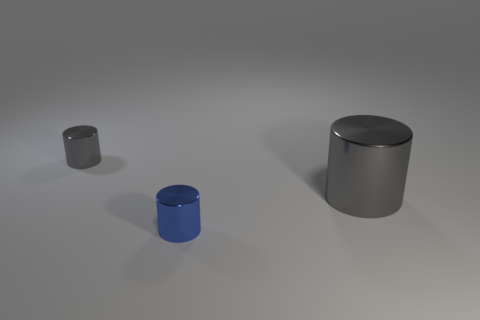Subtract all tiny metal cylinders. How many cylinders are left? 1 Add 2 gray metallic cylinders. How many objects exist? 5 Subtract all gray cylinders. How many cylinders are left? 1 Subtract 2 cylinders. How many cylinders are left? 1 Subtract all red balls. How many gray cylinders are left? 2 Add 2 large cylinders. How many large cylinders are left? 3 Add 2 small things. How many small things exist? 4 Subtract 0 green cylinders. How many objects are left? 3 Subtract all green cylinders. Subtract all red spheres. How many cylinders are left? 3 Subtract all blue metallic cylinders. Subtract all large gray things. How many objects are left? 1 